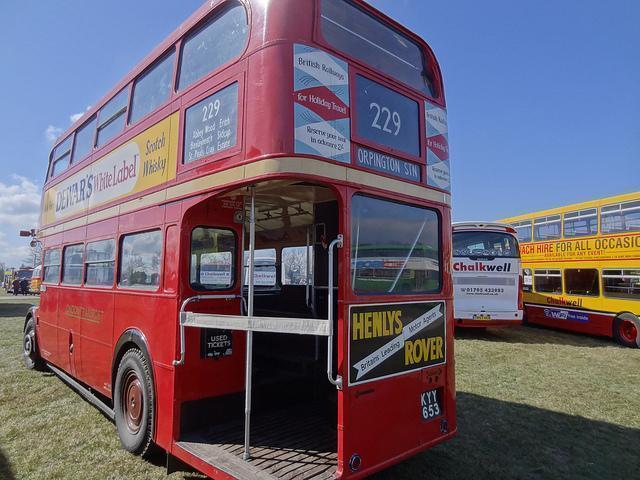What number is closest to the number at the top of the bus?
Indicate the correct response by choosing from the four available options to answer the question.
Options: 560, 803, 240, 121. 240. 